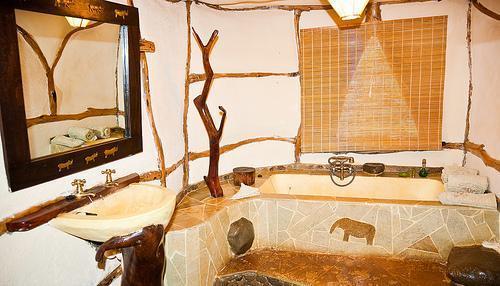How many mirrors are there?
Give a very brief answer. 1. 